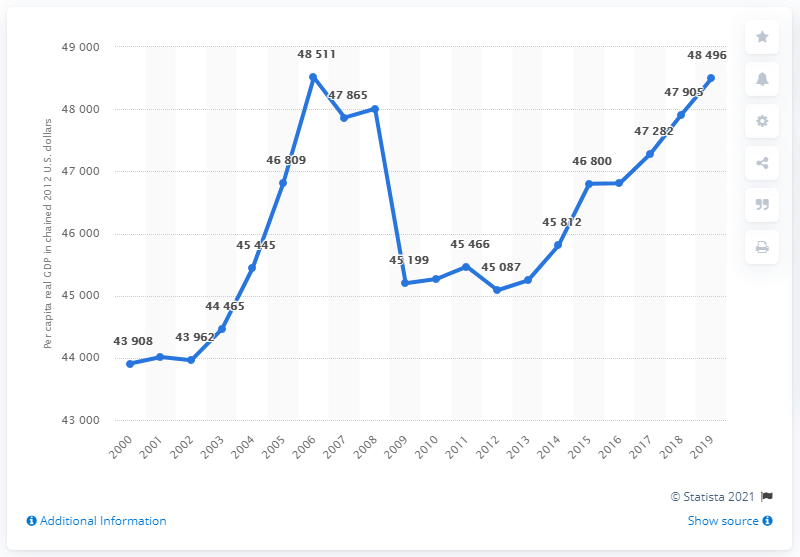Specify some key components in this picture. The per capita real GDP of North Carolina was calculated in 2012. 